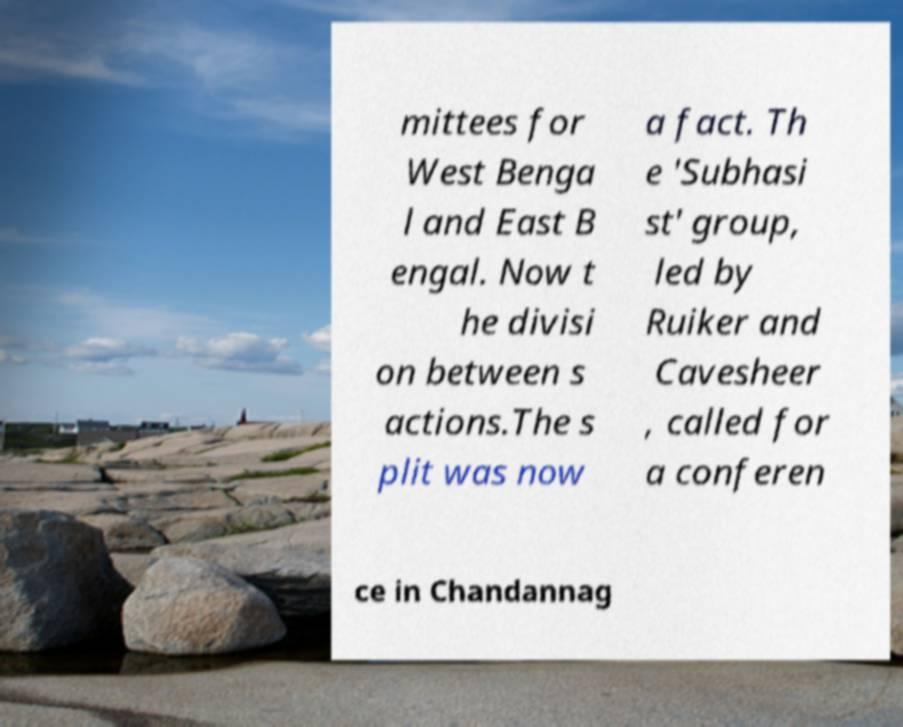Please read and relay the text visible in this image. What does it say? mittees for West Benga l and East B engal. Now t he divisi on between s actions.The s plit was now a fact. Th e 'Subhasi st' group, led by Ruiker and Cavesheer , called for a conferen ce in Chandannag 